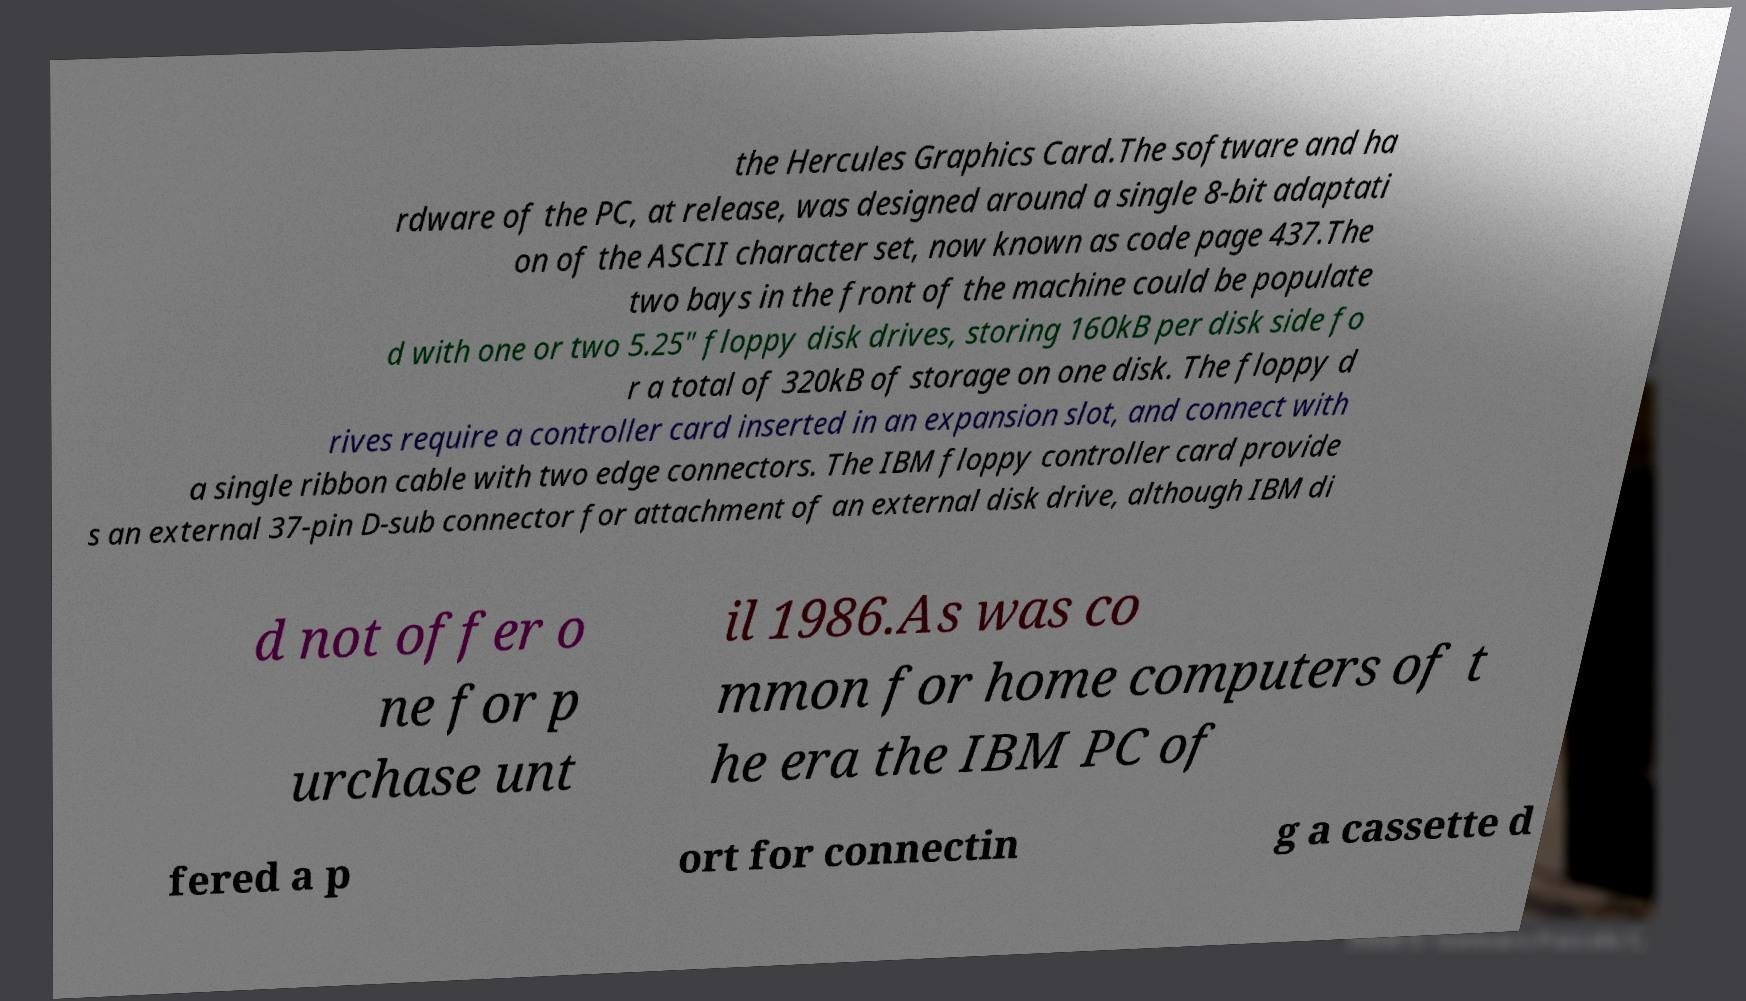What messages or text are displayed in this image? I need them in a readable, typed format. the Hercules Graphics Card.The software and ha rdware of the PC, at release, was designed around a single 8-bit adaptati on of the ASCII character set, now known as code page 437.The two bays in the front of the machine could be populate d with one or two 5.25″ floppy disk drives, storing 160kB per disk side fo r a total of 320kB of storage on one disk. The floppy d rives require a controller card inserted in an expansion slot, and connect with a single ribbon cable with two edge connectors. The IBM floppy controller card provide s an external 37-pin D-sub connector for attachment of an external disk drive, although IBM di d not offer o ne for p urchase unt il 1986.As was co mmon for home computers of t he era the IBM PC of fered a p ort for connectin g a cassette d 